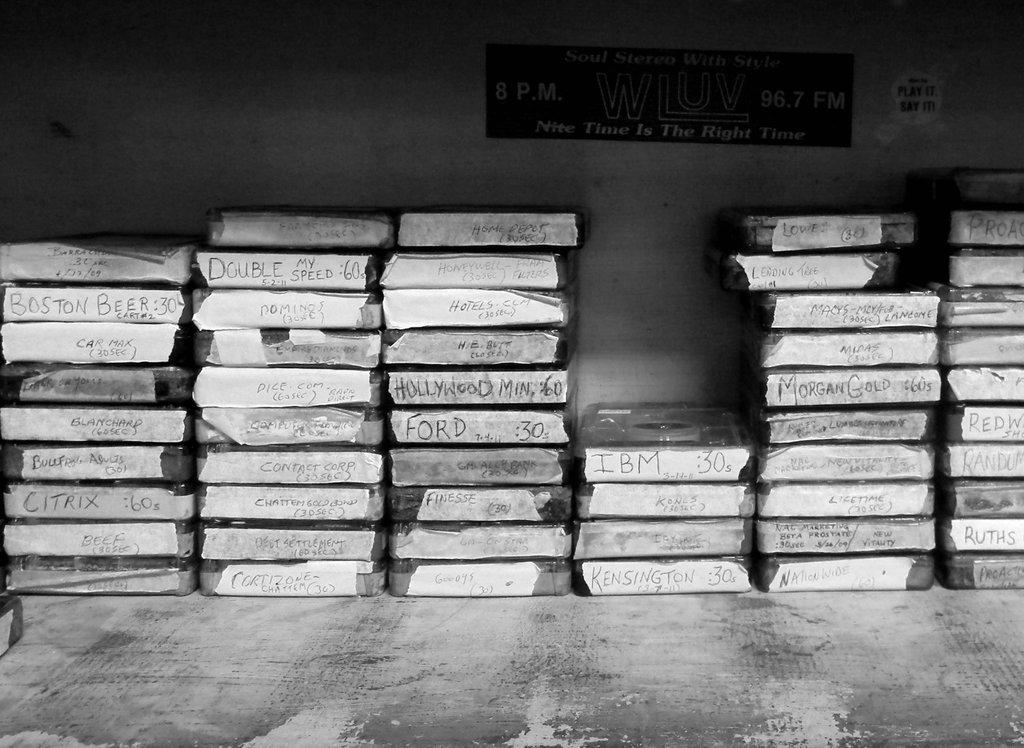<image>
Offer a succinct explanation of the picture presented. the word Ford is on the tape that is on a deck 